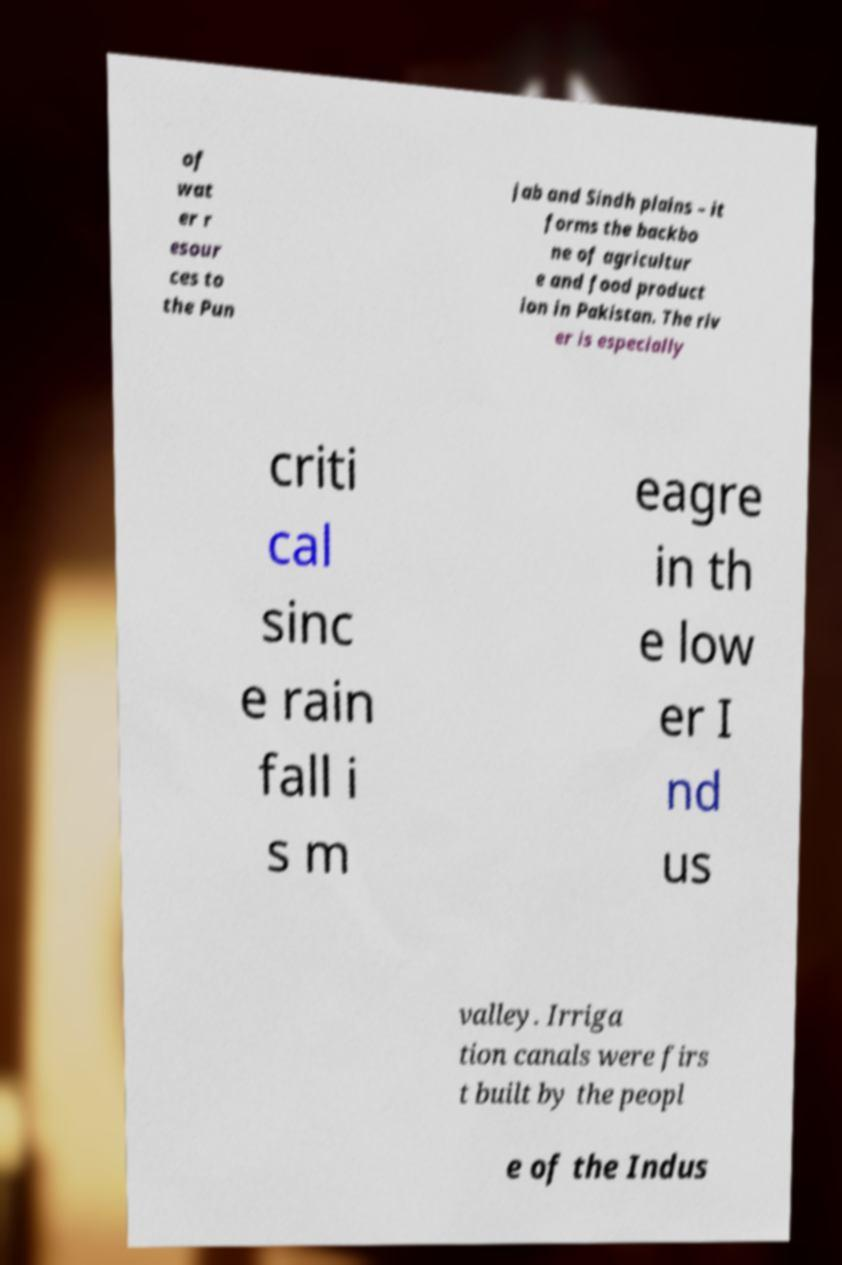I need the written content from this picture converted into text. Can you do that? of wat er r esour ces to the Pun jab and Sindh plains – it forms the backbo ne of agricultur e and food product ion in Pakistan. The riv er is especially criti cal sinc e rain fall i s m eagre in th e low er I nd us valley. Irriga tion canals were firs t built by the peopl e of the Indus 